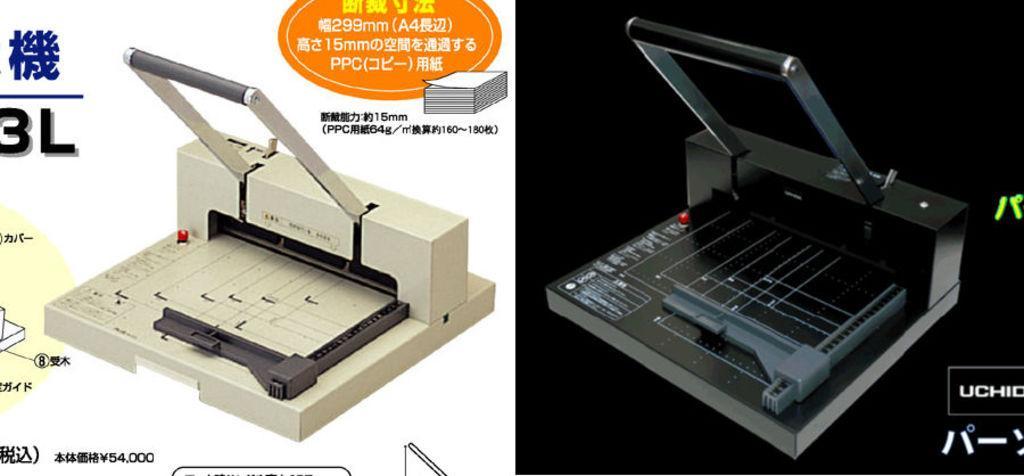Can you describe this image briefly? This is an edited picture. This picture is divided into two parts. The part on the left corner of the picture, we see a laminating machine in white color. Beside that, we see some text written on it. In the background, it is white in color. The part on the right corner of the picture is having a black color laminating machine and in the background, it is black in color. 